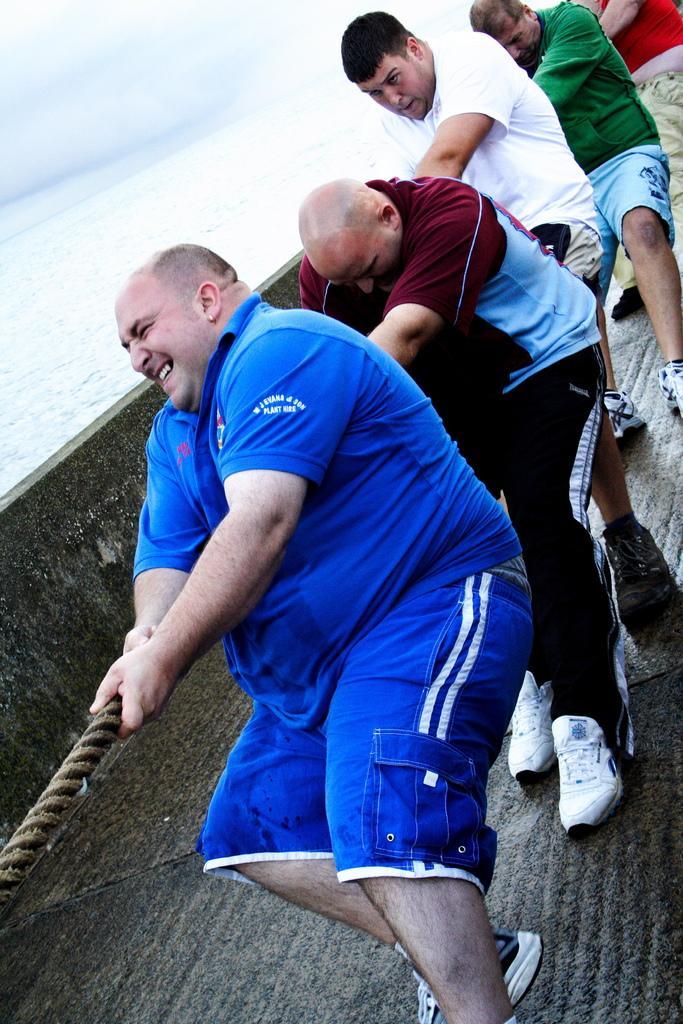How would you summarize this image in a sentence or two? This image is taken outdoors. At the top of the image there is the sky with clouds. In the background there is a sea with water. At the bottom of the image there is a ship on the sea. In the middle of the image a few people are standing on the ship and they are holding a rope in their hands. 